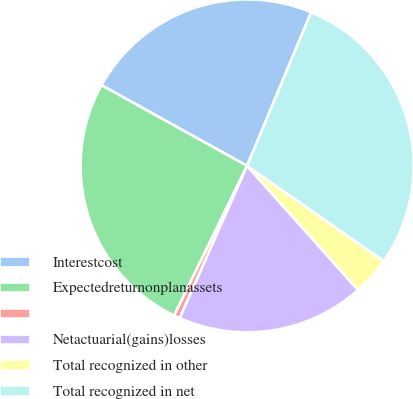Convert chart. <chart><loc_0><loc_0><loc_500><loc_500><pie_chart><fcel>Interestcost<fcel>Expectedreturnonplanassets<fcel>Unnamed: 2<fcel>Netactuarial(gains)losses<fcel>Total recognized in other<fcel>Total recognized in net<nl><fcel>23.24%<fcel>25.83%<fcel>0.59%<fcel>18.24%<fcel>3.71%<fcel>28.38%<nl></chart> 